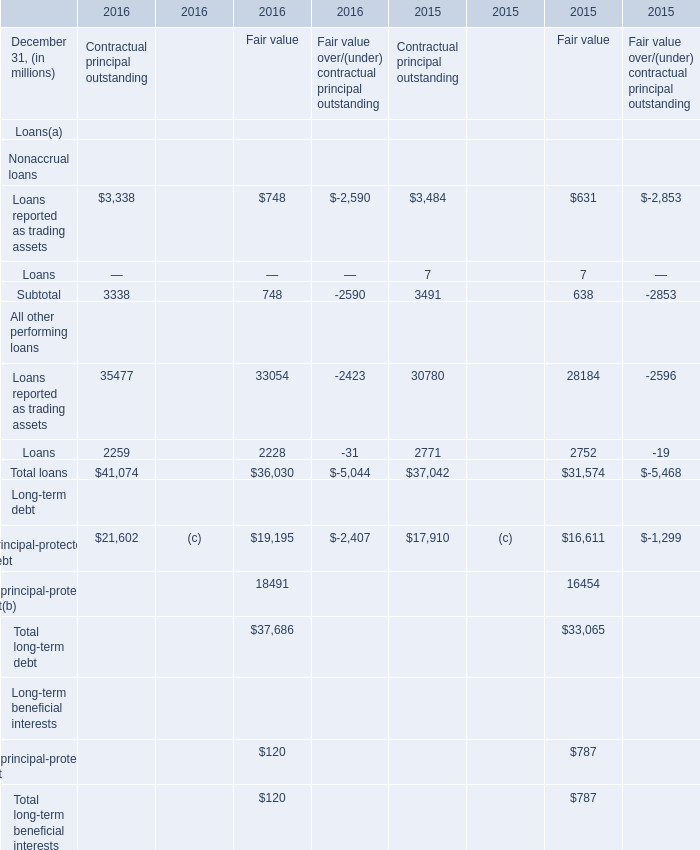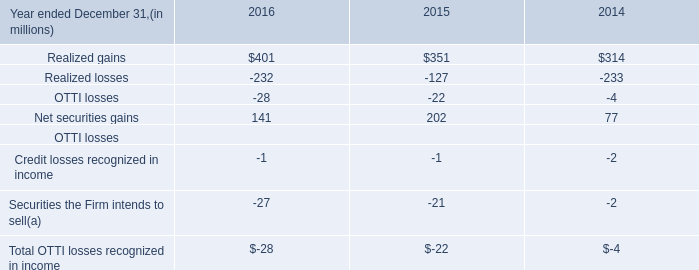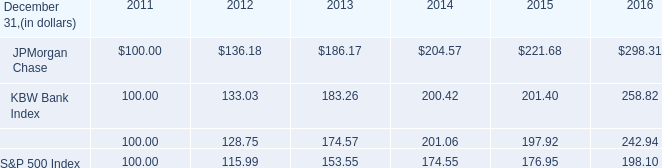What's the sum of the Net securities gains in the years where Loans for Contractual principal outstanding is positive? (in million) 
Computations: (141 + 202)
Answer: 343.0. 